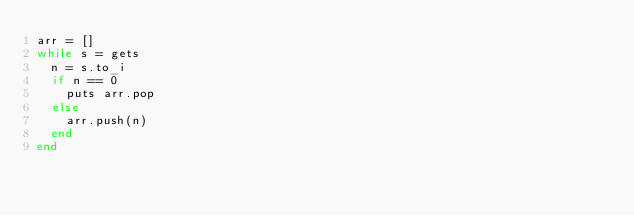Convert code to text. <code><loc_0><loc_0><loc_500><loc_500><_Ruby_>arr = []
while s = gets
  n = s.to_i
  if n == 0
    puts arr.pop
  else
    arr.push(n)
  end
end</code> 